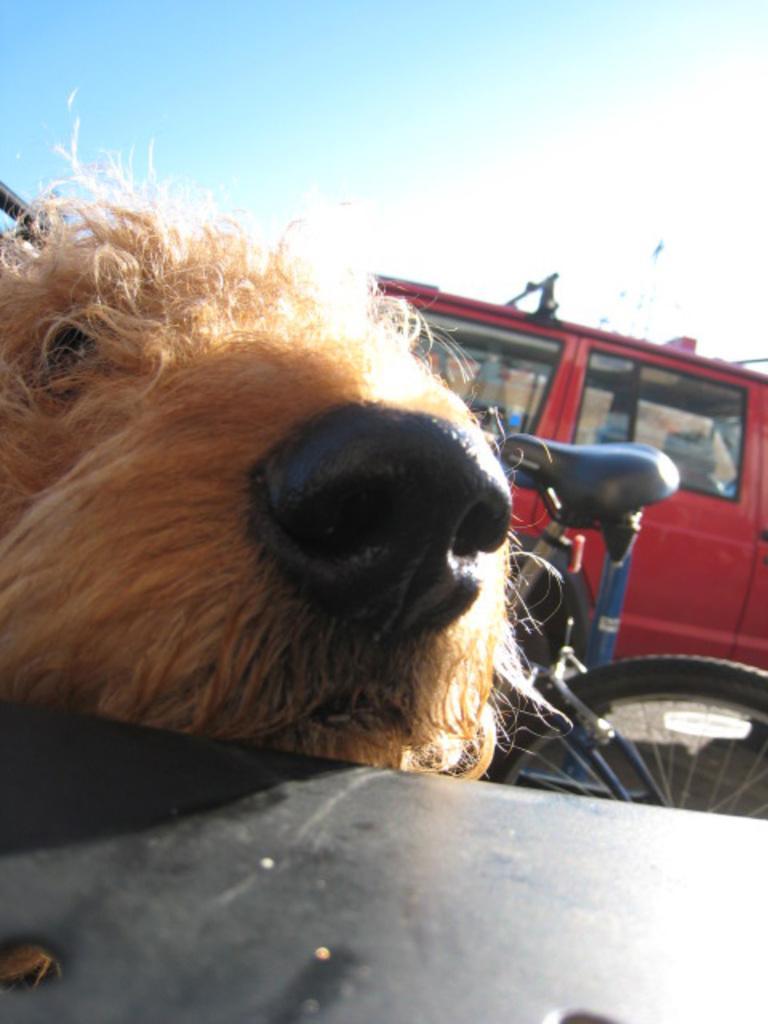How would you summarize this image in a sentence or two? In this image, we can see a dog and in the background, there is a van and we can see a bicycle. At the bottom, there is a table and at the top, there is sky. 